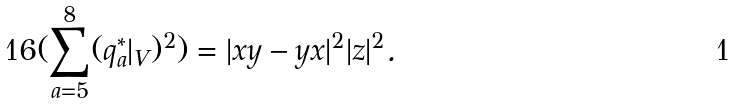Convert formula to latex. <formula><loc_0><loc_0><loc_500><loc_500>1 6 ( \sum _ { a = 5 } ^ { 8 } ( q ^ { * } _ { a } | _ { V } ) ^ { 2 } ) = | x y - y x | ^ { 2 } | z | ^ { 2 } .</formula> 